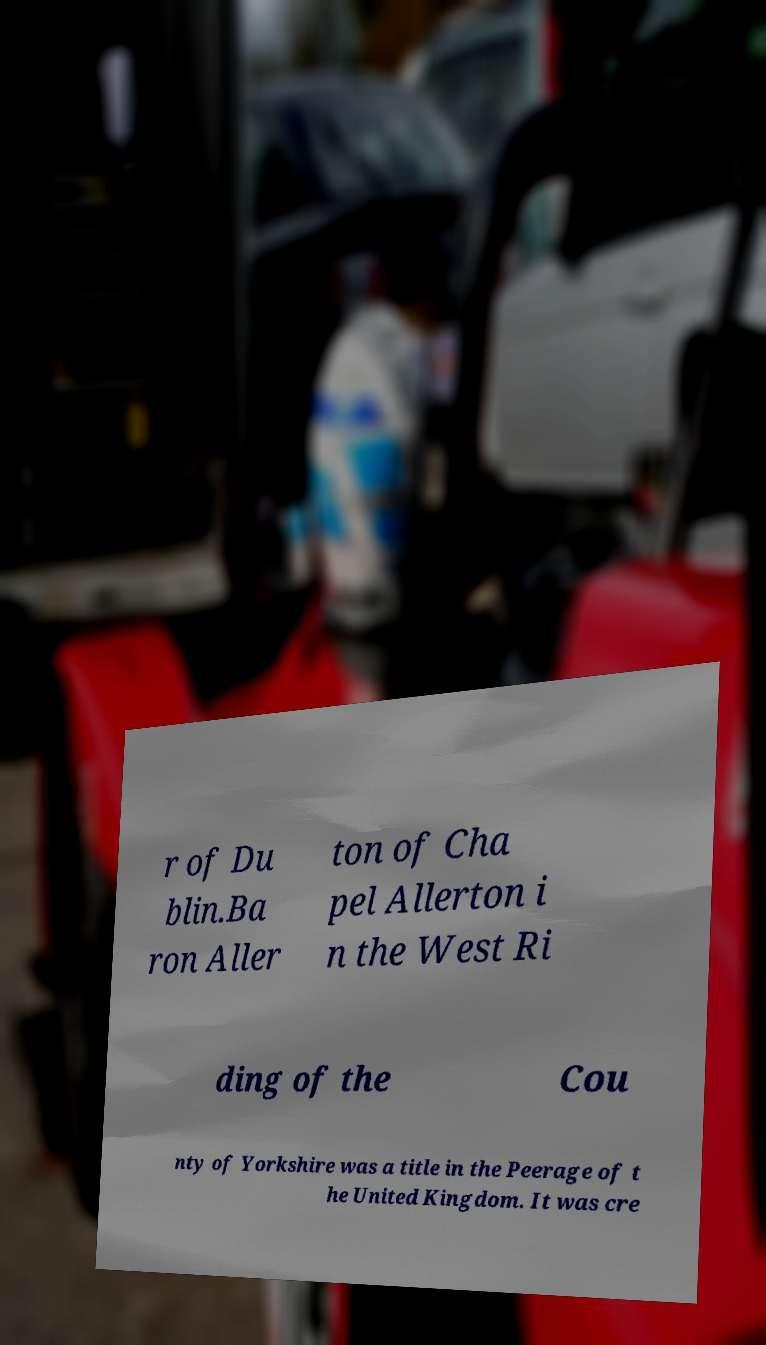There's text embedded in this image that I need extracted. Can you transcribe it verbatim? r of Du blin.Ba ron Aller ton of Cha pel Allerton i n the West Ri ding of the Cou nty of Yorkshire was a title in the Peerage of t he United Kingdom. It was cre 